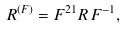<formula> <loc_0><loc_0><loc_500><loc_500>R ^ { ( F ) } = F ^ { 2 1 } R \, F ^ { - 1 } ,</formula> 